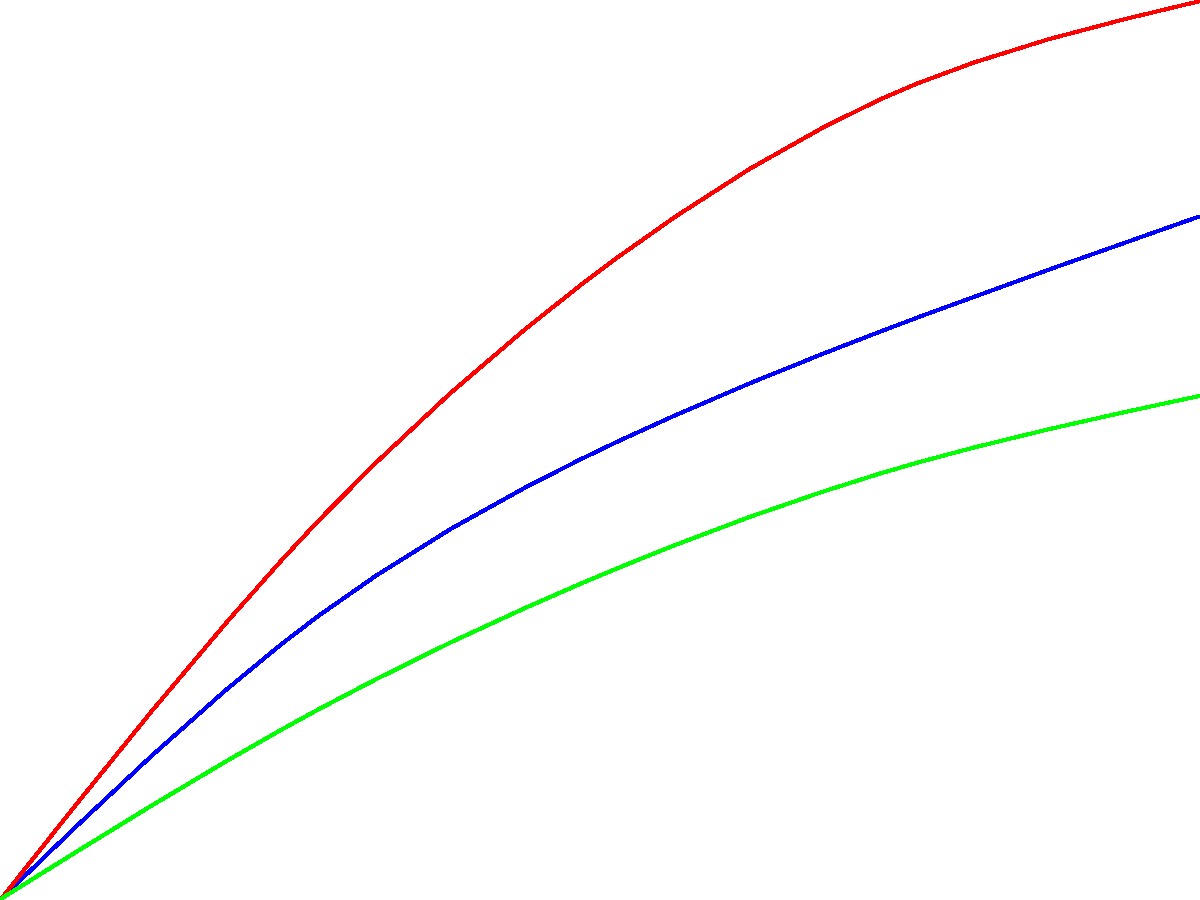Based on the graph showing heat transfer efficiency of various cooling systems for laboratory equipment, which system would be most suitable for a drug discovery process requiring rapid and efficient cooling of sensitive biological samples over an extended period? To determine the most suitable cooling system for a drug discovery process involving sensitive biological samples, we need to analyze the heat dissipation characteristics of each system over time:

1. Air-cooled system (blue line):
   - Moderate initial heat dissipation
   - Gradual increase over time
   - Reaches about 38 kW after 4 hours

2. Liquid-cooled system (red line):
   - High initial heat dissipation
   - Steeper increase over time
   - Reaches about 50 kW after 4 hours

3. Thermoelectric cooling (green line):
   - Lower initial heat dissipation
   - Slower increase over time
   - Reaches about 28 kW after 4 hours

For sensitive biological samples in drug discovery:
1. Rapid cooling is crucial to preserve sample integrity.
2. Efficient heat dissipation is necessary for extended periods.
3. Consistent cooling performance is important for reproducibility.

The liquid-cooled system offers:
1. The highest initial heat dissipation rate
2. The greatest overall heat dissipation capacity
3. A consistent increase in performance over time

These characteristics make it ideal for rapidly cooling samples and maintaining low temperatures over extended periods, which is crucial in drug discovery processes.

While the air-cooled system performs reasonably well, it doesn't match the efficiency of the liquid-cooled system. The thermoelectric cooling system, although potentially more precise for temperature control, has the lowest heat dissipation capacity, making it less suitable for rapid cooling of multiple samples in a high-throughput drug discovery environment.
Answer: Liquid-cooled system 